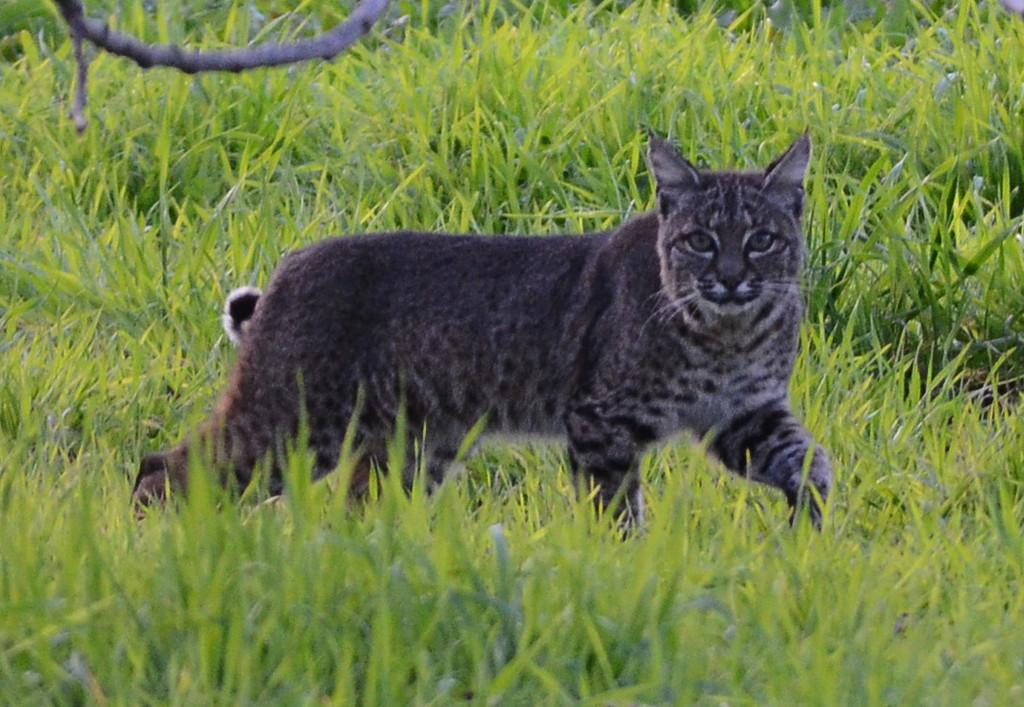What is the main subject of the image? The main subject of the image is a cat. Where is the cat located in the image? The cat is in the middle of the image. What type of natural environment is visible at the bottom of the image? There is grass at the bottom of the image. Can you tell me how many drawers are visible in the image? There are no drawers present in the image. What type of animal is playing with a ball in the image? There is no animal playing with a ball in the image. Where is the giraffe located in the image? There is no giraffe present in the image. 